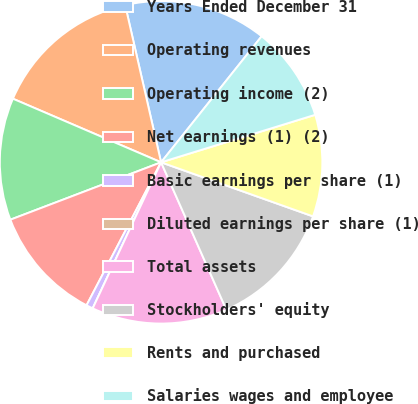Convert chart to OTSL. <chart><loc_0><loc_0><loc_500><loc_500><pie_chart><fcel>Years Ended December 31<fcel>Operating revenues<fcel>Operating income (2)<fcel>Net earnings (1) (2)<fcel>Basic earnings per share (1)<fcel>Diluted earnings per share (1)<fcel>Total assets<fcel>Stockholders' equity<fcel>Rents and purchased<fcel>Salaries wages and employee<nl><fcel>14.29%<fcel>14.97%<fcel>12.24%<fcel>11.56%<fcel>0.68%<fcel>0.0%<fcel>13.6%<fcel>12.92%<fcel>10.2%<fcel>9.52%<nl></chart> 